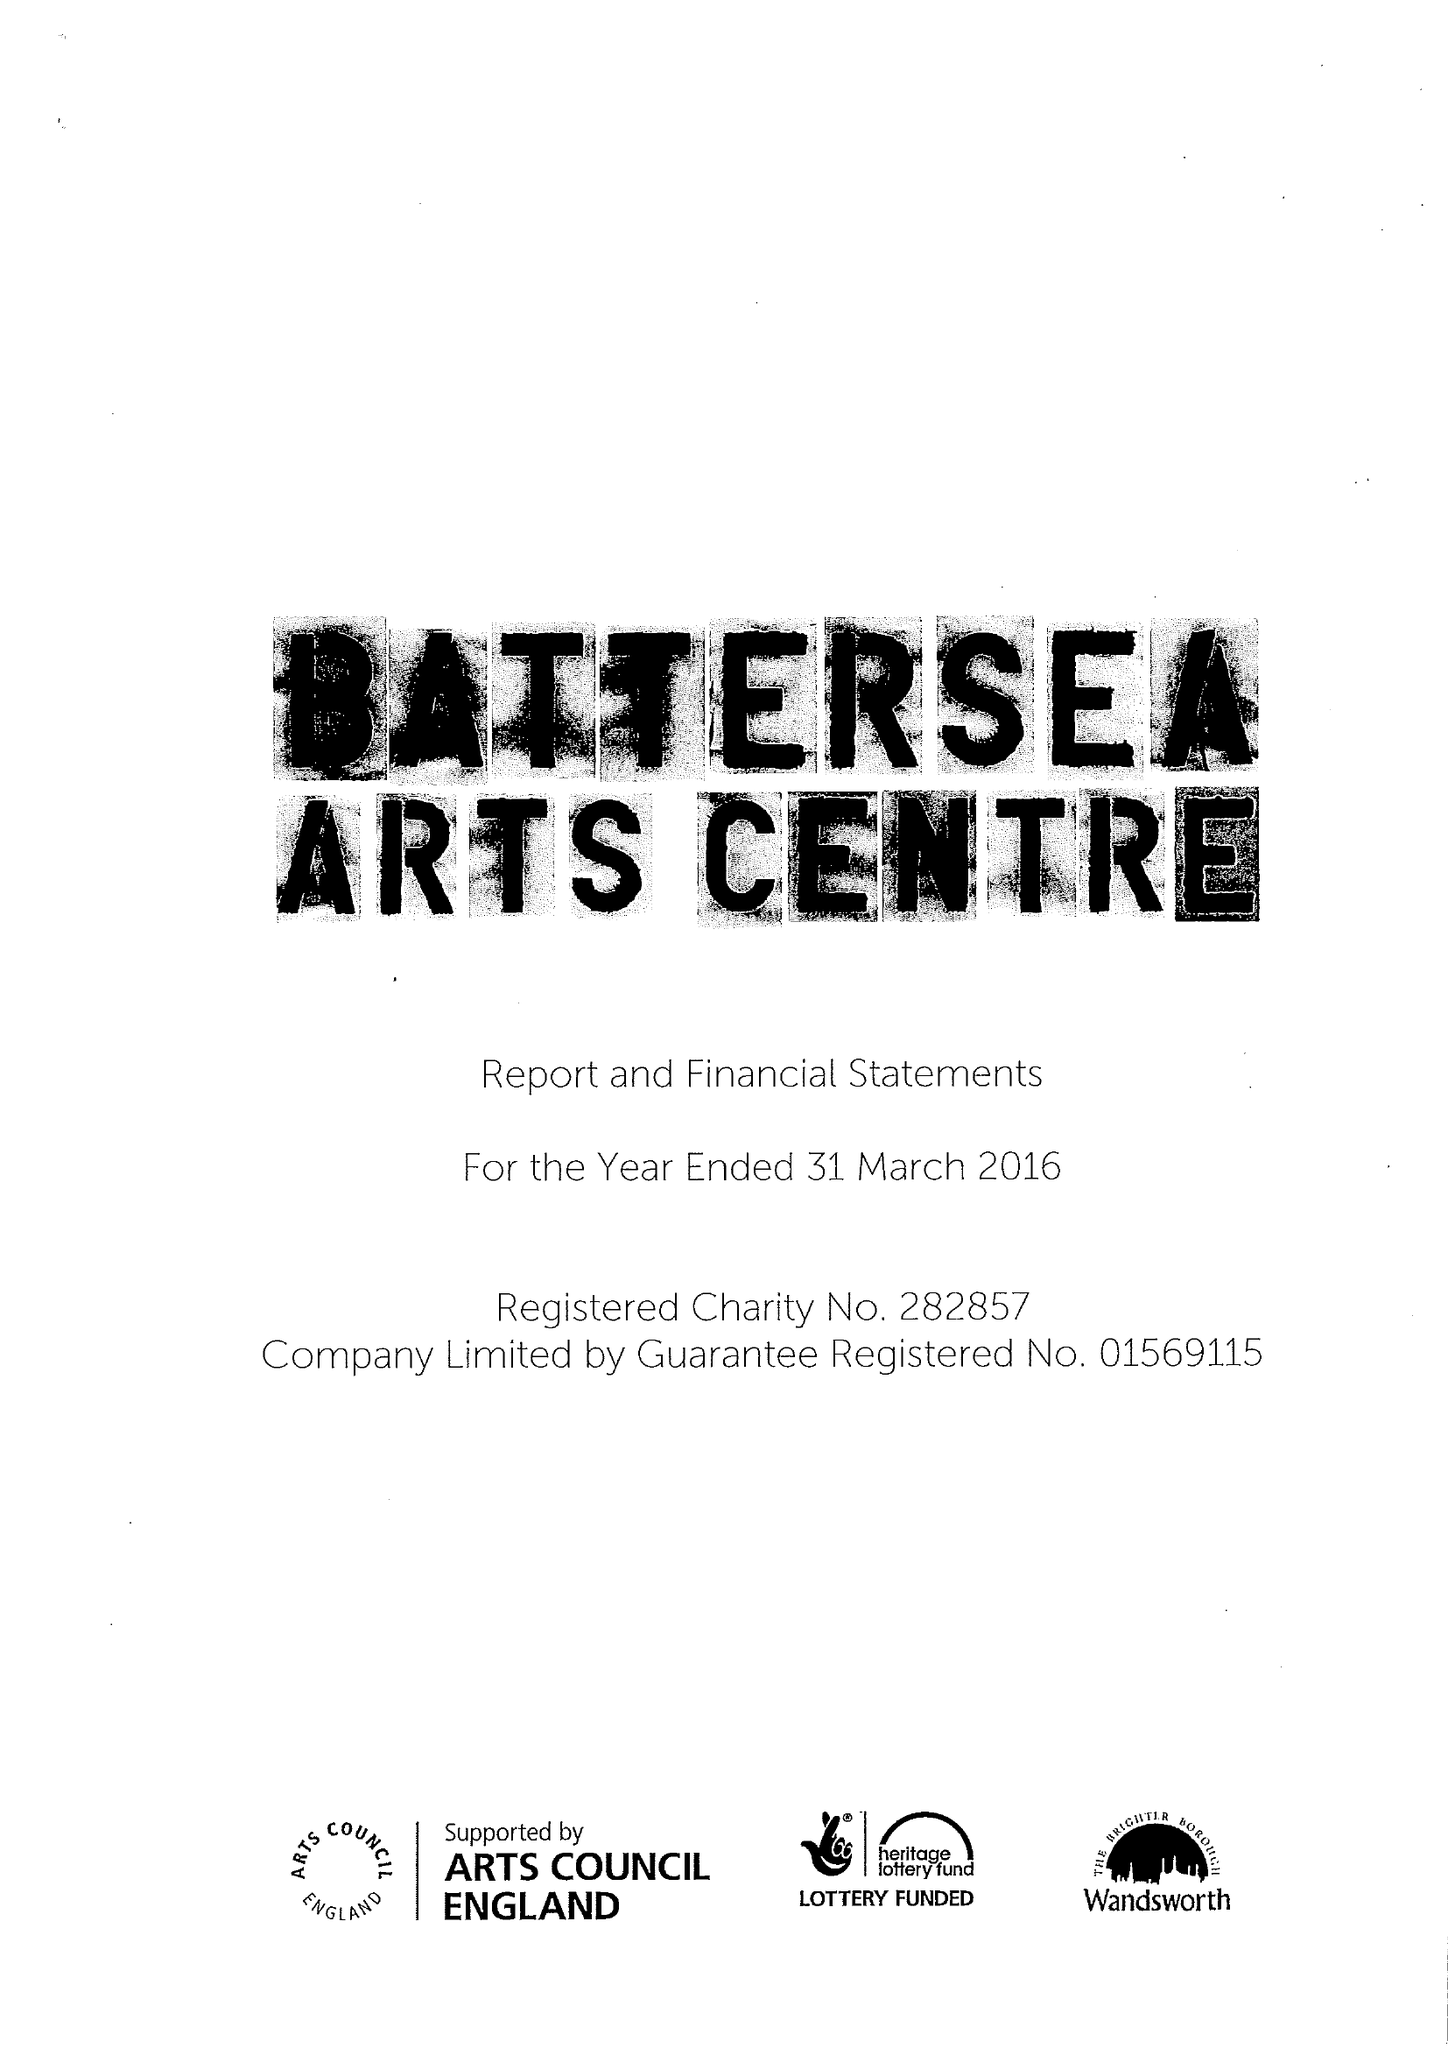What is the value for the spending_annually_in_british_pounds?
Answer the question using a single word or phrase. 5424327.00 